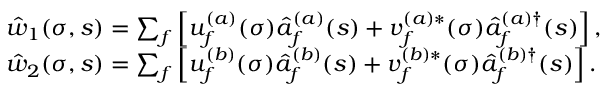Convert formula to latex. <formula><loc_0><loc_0><loc_500><loc_500>\begin{array} { r l } & { { \hat { w } } _ { 1 } ( \sigma , s ) = \sum _ { f } \left [ u _ { f } ^ { ( a ) } ( \sigma ) \hat { a } _ { f } ^ { ( a ) } ( s ) + v _ { f } ^ { ( a ) \ast } ( \sigma ) \hat { a } _ { f } ^ { ( a ) \dagger } ( s ) \right ] , } \\ & { { \hat { w } } _ { 2 } ( \sigma , s ) = \sum _ { f } \left [ u _ { f } ^ { ( b ) } ( \sigma ) \hat { a } _ { f } ^ { ( b ) } ( s ) + v _ { f } ^ { ( b ) \ast } ( \sigma ) \hat { a } _ { f } ^ { ( b ) \dagger } ( s ) \right ] . } \end{array}</formula> 